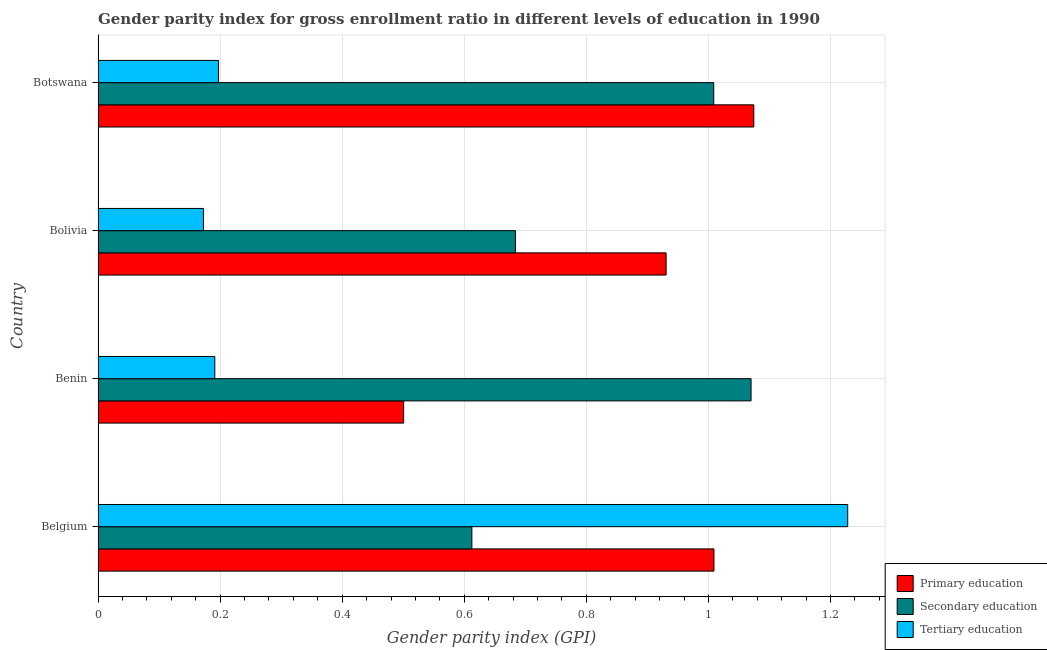Are the number of bars on each tick of the Y-axis equal?
Offer a terse response. Yes. How many bars are there on the 3rd tick from the bottom?
Give a very brief answer. 3. What is the label of the 1st group of bars from the top?
Your answer should be very brief. Botswana. In how many cases, is the number of bars for a given country not equal to the number of legend labels?
Offer a terse response. 0. What is the gender parity index in tertiary education in Belgium?
Offer a very short reply. 1.23. Across all countries, what is the maximum gender parity index in secondary education?
Ensure brevity in your answer.  1.07. Across all countries, what is the minimum gender parity index in tertiary education?
Make the answer very short. 0.17. In which country was the gender parity index in primary education maximum?
Provide a short and direct response. Botswana. What is the total gender parity index in secondary education in the graph?
Offer a very short reply. 3.37. What is the difference between the gender parity index in tertiary education in Bolivia and that in Botswana?
Offer a very short reply. -0.03. What is the difference between the gender parity index in primary education in Botswana and the gender parity index in secondary education in Belgium?
Provide a succinct answer. 0.46. What is the average gender parity index in tertiary education per country?
Offer a very short reply. 0.45. What is the difference between the gender parity index in primary education and gender parity index in tertiary education in Benin?
Offer a terse response. 0.31. What is the ratio of the gender parity index in tertiary education in Benin to that in Botswana?
Offer a very short reply. 0.97. Is the gender parity index in tertiary education in Belgium less than that in Bolivia?
Offer a terse response. No. Is the difference between the gender parity index in secondary education in Bolivia and Botswana greater than the difference between the gender parity index in tertiary education in Bolivia and Botswana?
Make the answer very short. No. What is the difference between the highest and the second highest gender parity index in primary education?
Ensure brevity in your answer.  0.07. What is the difference between the highest and the lowest gender parity index in secondary education?
Offer a very short reply. 0.46. In how many countries, is the gender parity index in tertiary education greater than the average gender parity index in tertiary education taken over all countries?
Keep it short and to the point. 1. Is the sum of the gender parity index in tertiary education in Belgium and Bolivia greater than the maximum gender parity index in secondary education across all countries?
Give a very brief answer. Yes. What does the 1st bar from the bottom in Bolivia represents?
Your response must be concise. Primary education. Is it the case that in every country, the sum of the gender parity index in primary education and gender parity index in secondary education is greater than the gender parity index in tertiary education?
Provide a short and direct response. Yes. How many bars are there?
Ensure brevity in your answer.  12. What is the difference between two consecutive major ticks on the X-axis?
Keep it short and to the point. 0.2. Are the values on the major ticks of X-axis written in scientific E-notation?
Provide a succinct answer. No. Does the graph contain any zero values?
Keep it short and to the point. No. Does the graph contain grids?
Make the answer very short. Yes. Where does the legend appear in the graph?
Provide a succinct answer. Bottom right. How many legend labels are there?
Your answer should be compact. 3. How are the legend labels stacked?
Ensure brevity in your answer.  Vertical. What is the title of the graph?
Your response must be concise. Gender parity index for gross enrollment ratio in different levels of education in 1990. What is the label or title of the X-axis?
Provide a succinct answer. Gender parity index (GPI). What is the label or title of the Y-axis?
Ensure brevity in your answer.  Country. What is the Gender parity index (GPI) of Primary education in Belgium?
Your response must be concise. 1.01. What is the Gender parity index (GPI) of Secondary education in Belgium?
Your answer should be very brief. 0.61. What is the Gender parity index (GPI) of Tertiary education in Belgium?
Ensure brevity in your answer.  1.23. What is the Gender parity index (GPI) of Primary education in Benin?
Your answer should be compact. 0.5. What is the Gender parity index (GPI) in Secondary education in Benin?
Ensure brevity in your answer.  1.07. What is the Gender parity index (GPI) in Tertiary education in Benin?
Provide a succinct answer. 0.19. What is the Gender parity index (GPI) of Primary education in Bolivia?
Your answer should be compact. 0.93. What is the Gender parity index (GPI) of Secondary education in Bolivia?
Ensure brevity in your answer.  0.68. What is the Gender parity index (GPI) in Tertiary education in Bolivia?
Your answer should be compact. 0.17. What is the Gender parity index (GPI) of Primary education in Botswana?
Your answer should be very brief. 1.07. What is the Gender parity index (GPI) of Secondary education in Botswana?
Offer a terse response. 1.01. What is the Gender parity index (GPI) in Tertiary education in Botswana?
Give a very brief answer. 0.2. Across all countries, what is the maximum Gender parity index (GPI) of Primary education?
Your answer should be very brief. 1.07. Across all countries, what is the maximum Gender parity index (GPI) in Secondary education?
Offer a very short reply. 1.07. Across all countries, what is the maximum Gender parity index (GPI) of Tertiary education?
Provide a short and direct response. 1.23. Across all countries, what is the minimum Gender parity index (GPI) in Primary education?
Your answer should be very brief. 0.5. Across all countries, what is the minimum Gender parity index (GPI) in Secondary education?
Make the answer very short. 0.61. Across all countries, what is the minimum Gender parity index (GPI) of Tertiary education?
Make the answer very short. 0.17. What is the total Gender parity index (GPI) of Primary education in the graph?
Ensure brevity in your answer.  3.51. What is the total Gender parity index (GPI) of Secondary education in the graph?
Keep it short and to the point. 3.37. What is the total Gender parity index (GPI) in Tertiary education in the graph?
Your answer should be very brief. 1.79. What is the difference between the Gender parity index (GPI) in Primary education in Belgium and that in Benin?
Ensure brevity in your answer.  0.51. What is the difference between the Gender parity index (GPI) of Secondary education in Belgium and that in Benin?
Your answer should be compact. -0.46. What is the difference between the Gender parity index (GPI) of Tertiary education in Belgium and that in Benin?
Offer a terse response. 1.04. What is the difference between the Gender parity index (GPI) in Primary education in Belgium and that in Bolivia?
Offer a terse response. 0.08. What is the difference between the Gender parity index (GPI) of Secondary education in Belgium and that in Bolivia?
Ensure brevity in your answer.  -0.07. What is the difference between the Gender parity index (GPI) in Tertiary education in Belgium and that in Bolivia?
Offer a very short reply. 1.06. What is the difference between the Gender parity index (GPI) of Primary education in Belgium and that in Botswana?
Your response must be concise. -0.07. What is the difference between the Gender parity index (GPI) in Secondary education in Belgium and that in Botswana?
Your answer should be very brief. -0.4. What is the difference between the Gender parity index (GPI) in Tertiary education in Belgium and that in Botswana?
Your response must be concise. 1.03. What is the difference between the Gender parity index (GPI) of Primary education in Benin and that in Bolivia?
Provide a short and direct response. -0.43. What is the difference between the Gender parity index (GPI) of Secondary education in Benin and that in Bolivia?
Your answer should be very brief. 0.39. What is the difference between the Gender parity index (GPI) of Tertiary education in Benin and that in Bolivia?
Give a very brief answer. 0.02. What is the difference between the Gender parity index (GPI) of Primary education in Benin and that in Botswana?
Provide a succinct answer. -0.57. What is the difference between the Gender parity index (GPI) in Secondary education in Benin and that in Botswana?
Give a very brief answer. 0.06. What is the difference between the Gender parity index (GPI) of Tertiary education in Benin and that in Botswana?
Ensure brevity in your answer.  -0.01. What is the difference between the Gender parity index (GPI) of Primary education in Bolivia and that in Botswana?
Ensure brevity in your answer.  -0.14. What is the difference between the Gender parity index (GPI) of Secondary education in Bolivia and that in Botswana?
Provide a short and direct response. -0.32. What is the difference between the Gender parity index (GPI) of Tertiary education in Bolivia and that in Botswana?
Your answer should be compact. -0.02. What is the difference between the Gender parity index (GPI) of Primary education in Belgium and the Gender parity index (GPI) of Secondary education in Benin?
Your answer should be compact. -0.06. What is the difference between the Gender parity index (GPI) of Primary education in Belgium and the Gender parity index (GPI) of Tertiary education in Benin?
Your answer should be very brief. 0.82. What is the difference between the Gender parity index (GPI) in Secondary education in Belgium and the Gender parity index (GPI) in Tertiary education in Benin?
Ensure brevity in your answer.  0.42. What is the difference between the Gender parity index (GPI) in Primary education in Belgium and the Gender parity index (GPI) in Secondary education in Bolivia?
Make the answer very short. 0.33. What is the difference between the Gender parity index (GPI) in Primary education in Belgium and the Gender parity index (GPI) in Tertiary education in Bolivia?
Your answer should be very brief. 0.84. What is the difference between the Gender parity index (GPI) in Secondary education in Belgium and the Gender parity index (GPI) in Tertiary education in Bolivia?
Offer a very short reply. 0.44. What is the difference between the Gender parity index (GPI) in Primary education in Belgium and the Gender parity index (GPI) in Secondary education in Botswana?
Your answer should be compact. 0. What is the difference between the Gender parity index (GPI) in Primary education in Belgium and the Gender parity index (GPI) in Tertiary education in Botswana?
Provide a short and direct response. 0.81. What is the difference between the Gender parity index (GPI) in Secondary education in Belgium and the Gender parity index (GPI) in Tertiary education in Botswana?
Keep it short and to the point. 0.41. What is the difference between the Gender parity index (GPI) of Primary education in Benin and the Gender parity index (GPI) of Secondary education in Bolivia?
Your answer should be very brief. -0.18. What is the difference between the Gender parity index (GPI) in Primary education in Benin and the Gender parity index (GPI) in Tertiary education in Bolivia?
Your response must be concise. 0.33. What is the difference between the Gender parity index (GPI) of Secondary education in Benin and the Gender parity index (GPI) of Tertiary education in Bolivia?
Offer a very short reply. 0.9. What is the difference between the Gender parity index (GPI) in Primary education in Benin and the Gender parity index (GPI) in Secondary education in Botswana?
Offer a very short reply. -0.51. What is the difference between the Gender parity index (GPI) of Primary education in Benin and the Gender parity index (GPI) of Tertiary education in Botswana?
Your answer should be compact. 0.3. What is the difference between the Gender parity index (GPI) of Secondary education in Benin and the Gender parity index (GPI) of Tertiary education in Botswana?
Offer a terse response. 0.87. What is the difference between the Gender parity index (GPI) in Primary education in Bolivia and the Gender parity index (GPI) in Secondary education in Botswana?
Offer a terse response. -0.08. What is the difference between the Gender parity index (GPI) in Primary education in Bolivia and the Gender parity index (GPI) in Tertiary education in Botswana?
Your response must be concise. 0.73. What is the difference between the Gender parity index (GPI) in Secondary education in Bolivia and the Gender parity index (GPI) in Tertiary education in Botswana?
Keep it short and to the point. 0.49. What is the average Gender parity index (GPI) in Primary education per country?
Provide a short and direct response. 0.88. What is the average Gender parity index (GPI) of Secondary education per country?
Provide a succinct answer. 0.84. What is the average Gender parity index (GPI) of Tertiary education per country?
Give a very brief answer. 0.45. What is the difference between the Gender parity index (GPI) in Primary education and Gender parity index (GPI) in Secondary education in Belgium?
Offer a very short reply. 0.4. What is the difference between the Gender parity index (GPI) of Primary education and Gender parity index (GPI) of Tertiary education in Belgium?
Your answer should be very brief. -0.22. What is the difference between the Gender parity index (GPI) in Secondary education and Gender parity index (GPI) in Tertiary education in Belgium?
Make the answer very short. -0.62. What is the difference between the Gender parity index (GPI) in Primary education and Gender parity index (GPI) in Secondary education in Benin?
Provide a succinct answer. -0.57. What is the difference between the Gender parity index (GPI) in Primary education and Gender parity index (GPI) in Tertiary education in Benin?
Offer a very short reply. 0.31. What is the difference between the Gender parity index (GPI) of Secondary education and Gender parity index (GPI) of Tertiary education in Benin?
Offer a very short reply. 0.88. What is the difference between the Gender parity index (GPI) in Primary education and Gender parity index (GPI) in Secondary education in Bolivia?
Your response must be concise. 0.25. What is the difference between the Gender parity index (GPI) of Primary education and Gender parity index (GPI) of Tertiary education in Bolivia?
Provide a succinct answer. 0.76. What is the difference between the Gender parity index (GPI) in Secondary education and Gender parity index (GPI) in Tertiary education in Bolivia?
Keep it short and to the point. 0.51. What is the difference between the Gender parity index (GPI) in Primary education and Gender parity index (GPI) in Secondary education in Botswana?
Give a very brief answer. 0.07. What is the difference between the Gender parity index (GPI) of Primary education and Gender parity index (GPI) of Tertiary education in Botswana?
Your response must be concise. 0.88. What is the difference between the Gender parity index (GPI) in Secondary education and Gender parity index (GPI) in Tertiary education in Botswana?
Your answer should be compact. 0.81. What is the ratio of the Gender parity index (GPI) in Primary education in Belgium to that in Benin?
Your answer should be very brief. 2.02. What is the ratio of the Gender parity index (GPI) of Secondary education in Belgium to that in Benin?
Offer a terse response. 0.57. What is the ratio of the Gender parity index (GPI) of Tertiary education in Belgium to that in Benin?
Provide a short and direct response. 6.42. What is the ratio of the Gender parity index (GPI) in Primary education in Belgium to that in Bolivia?
Ensure brevity in your answer.  1.08. What is the ratio of the Gender parity index (GPI) of Secondary education in Belgium to that in Bolivia?
Provide a succinct answer. 0.9. What is the ratio of the Gender parity index (GPI) in Tertiary education in Belgium to that in Bolivia?
Your answer should be compact. 7.12. What is the ratio of the Gender parity index (GPI) of Primary education in Belgium to that in Botswana?
Your answer should be very brief. 0.94. What is the ratio of the Gender parity index (GPI) in Secondary education in Belgium to that in Botswana?
Provide a short and direct response. 0.61. What is the ratio of the Gender parity index (GPI) in Tertiary education in Belgium to that in Botswana?
Your answer should be compact. 6.22. What is the ratio of the Gender parity index (GPI) in Primary education in Benin to that in Bolivia?
Your answer should be very brief. 0.54. What is the ratio of the Gender parity index (GPI) of Secondary education in Benin to that in Bolivia?
Keep it short and to the point. 1.56. What is the ratio of the Gender parity index (GPI) of Tertiary education in Benin to that in Bolivia?
Keep it short and to the point. 1.11. What is the ratio of the Gender parity index (GPI) in Primary education in Benin to that in Botswana?
Your answer should be very brief. 0.47. What is the ratio of the Gender parity index (GPI) in Secondary education in Benin to that in Botswana?
Your answer should be compact. 1.06. What is the ratio of the Gender parity index (GPI) in Primary education in Bolivia to that in Botswana?
Your answer should be very brief. 0.87. What is the ratio of the Gender parity index (GPI) in Secondary education in Bolivia to that in Botswana?
Offer a very short reply. 0.68. What is the ratio of the Gender parity index (GPI) in Tertiary education in Bolivia to that in Botswana?
Your response must be concise. 0.87. What is the difference between the highest and the second highest Gender parity index (GPI) in Primary education?
Make the answer very short. 0.07. What is the difference between the highest and the second highest Gender parity index (GPI) in Secondary education?
Your answer should be compact. 0.06. What is the difference between the highest and the second highest Gender parity index (GPI) of Tertiary education?
Provide a succinct answer. 1.03. What is the difference between the highest and the lowest Gender parity index (GPI) in Primary education?
Offer a terse response. 0.57. What is the difference between the highest and the lowest Gender parity index (GPI) of Secondary education?
Give a very brief answer. 0.46. What is the difference between the highest and the lowest Gender parity index (GPI) in Tertiary education?
Your response must be concise. 1.06. 